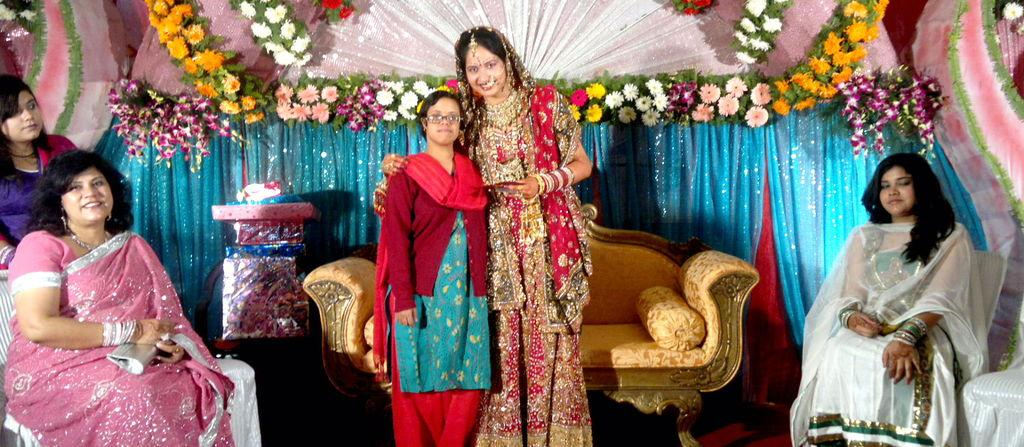What is the woman in the image doing? The woman is sitting on a chair. Are there any other people in the image? Yes, there are two women standing near a sofa. What can be seen hanging or placed on the wall? There is a cloth decoration with flowers. What else can be seen in the image? There are gifts present. What type of bushes can be seen in the image? There are no bushes present in the image. What kind of rock is being used as bait in the image? There is no fishing or bait present in the image. 